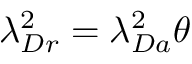Convert formula to latex. <formula><loc_0><loc_0><loc_500><loc_500>\lambda _ { D r } ^ { 2 } = \lambda _ { D a } ^ { 2 } \theta</formula> 